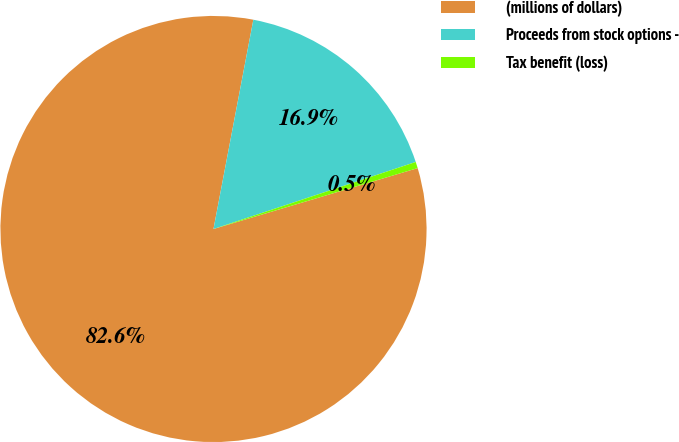Convert chart. <chart><loc_0><loc_0><loc_500><loc_500><pie_chart><fcel>(millions of dollars)<fcel>Proceeds from stock options -<fcel>Tax benefit (loss)<nl><fcel>82.61%<fcel>16.91%<fcel>0.48%<nl></chart> 